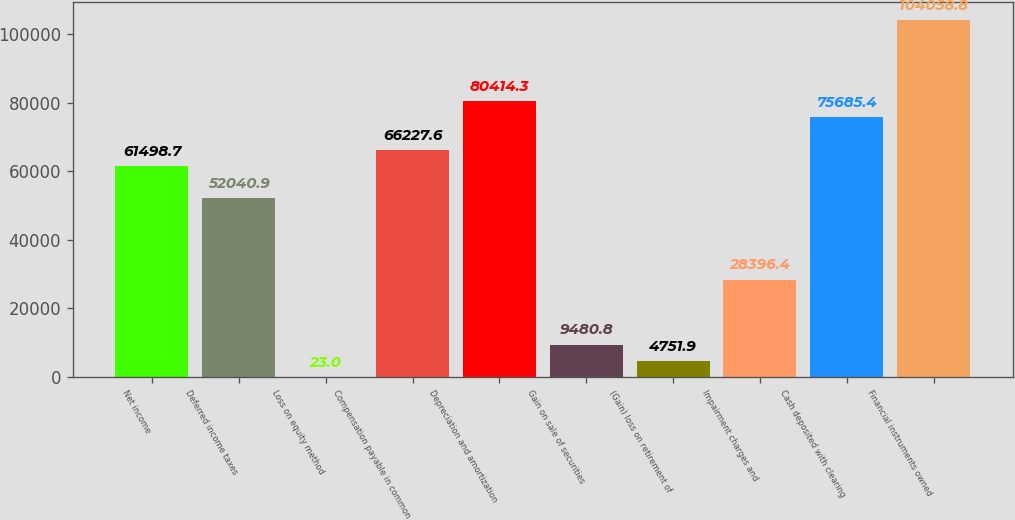Convert chart. <chart><loc_0><loc_0><loc_500><loc_500><bar_chart><fcel>Net income<fcel>Deferred income taxes<fcel>Loss on equity method<fcel>Compensation payable in common<fcel>Depreciation and amortization<fcel>Gain on sale of securities<fcel>(Gain) loss on retirement of<fcel>Impairment charges and<fcel>Cash deposited with clearing<fcel>Financial instruments owned<nl><fcel>61498.7<fcel>52040.9<fcel>23<fcel>66227.6<fcel>80414.3<fcel>9480.8<fcel>4751.9<fcel>28396.4<fcel>75685.4<fcel>104059<nl></chart> 